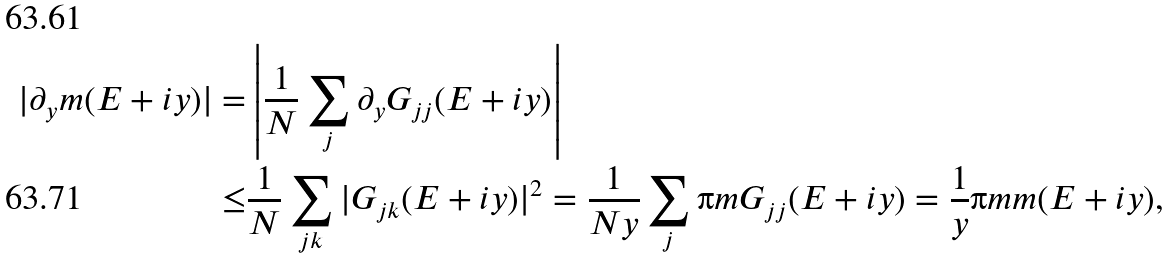Convert formula to latex. <formula><loc_0><loc_0><loc_500><loc_500>| \partial _ { y } m ( E + i y ) | = & \left | \frac { 1 } { N } \sum _ { j } \partial _ { y } G _ { j j } ( E + i y ) \right | \\ \leq & \frac { 1 } { N } \sum _ { j k } | G _ { j k } ( E + i y ) | ^ { 2 } = \frac { 1 } { N y } \sum _ { j } \i m G _ { j j } ( E + i y ) = \frac { 1 } { y } \i m m ( E + i y ) ,</formula> 